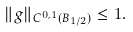Convert formula to latex. <formula><loc_0><loc_0><loc_500><loc_500>\| g \| _ { C ^ { 0 , 1 } ( B _ { 1 / 2 } ) } \leq 1 .</formula> 